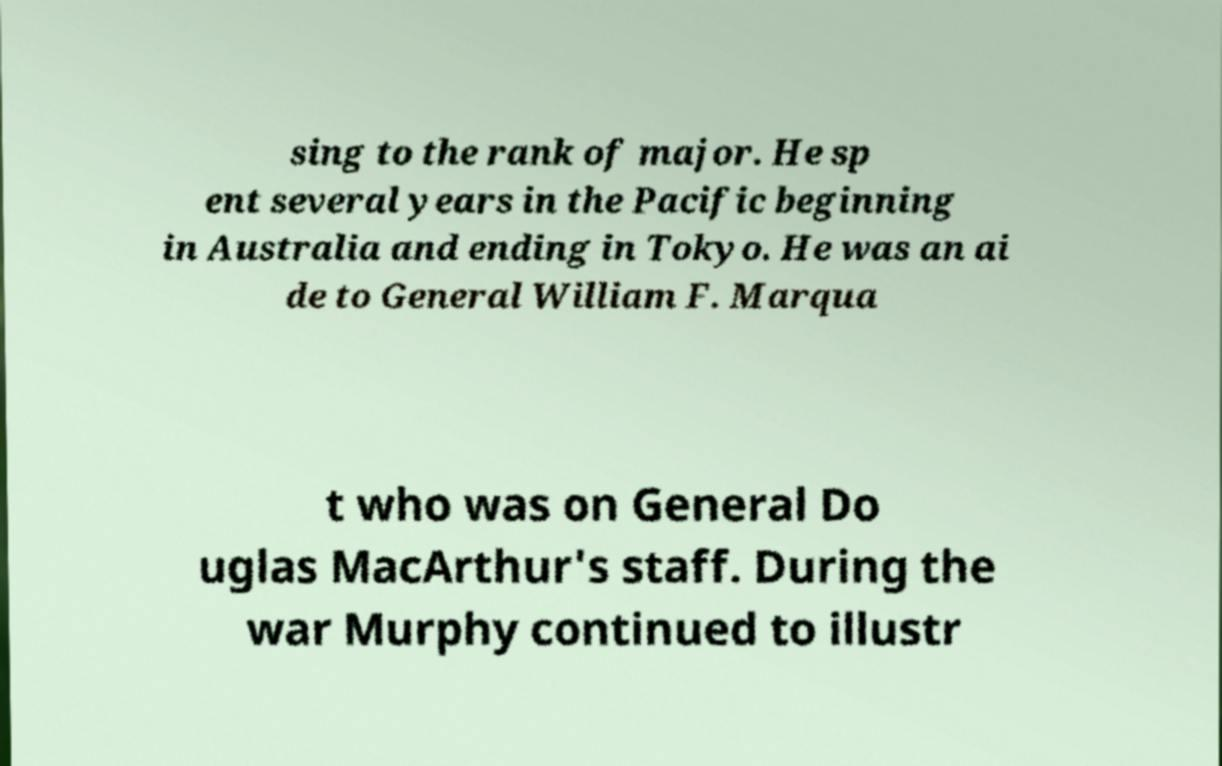Please identify and transcribe the text found in this image. sing to the rank of major. He sp ent several years in the Pacific beginning in Australia and ending in Tokyo. He was an ai de to General William F. Marqua t who was on General Do uglas MacArthur's staff. During the war Murphy continued to illustr 